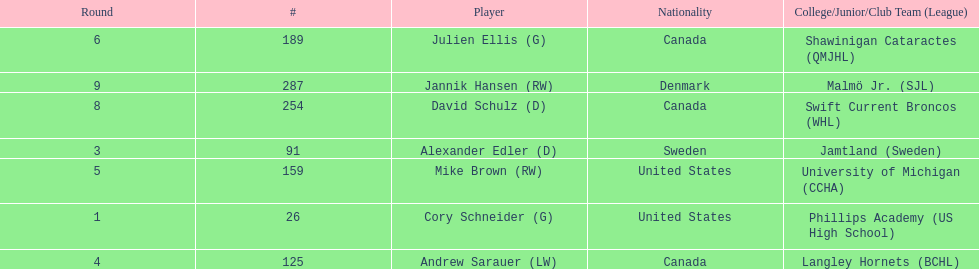Which players are not from denmark? Cory Schneider (G), Alexander Edler (D), Andrew Sarauer (LW), Mike Brown (RW), Julien Ellis (G), David Schulz (D). 